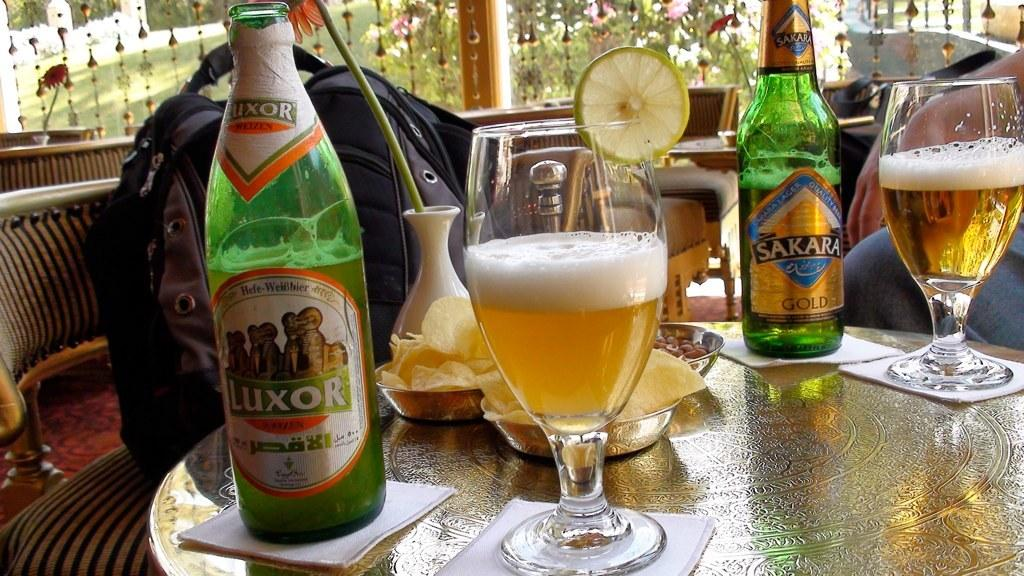Provide a one-sentence caption for the provided image. A table shows two bottles, one called Luxor and two full glasses of beer. 